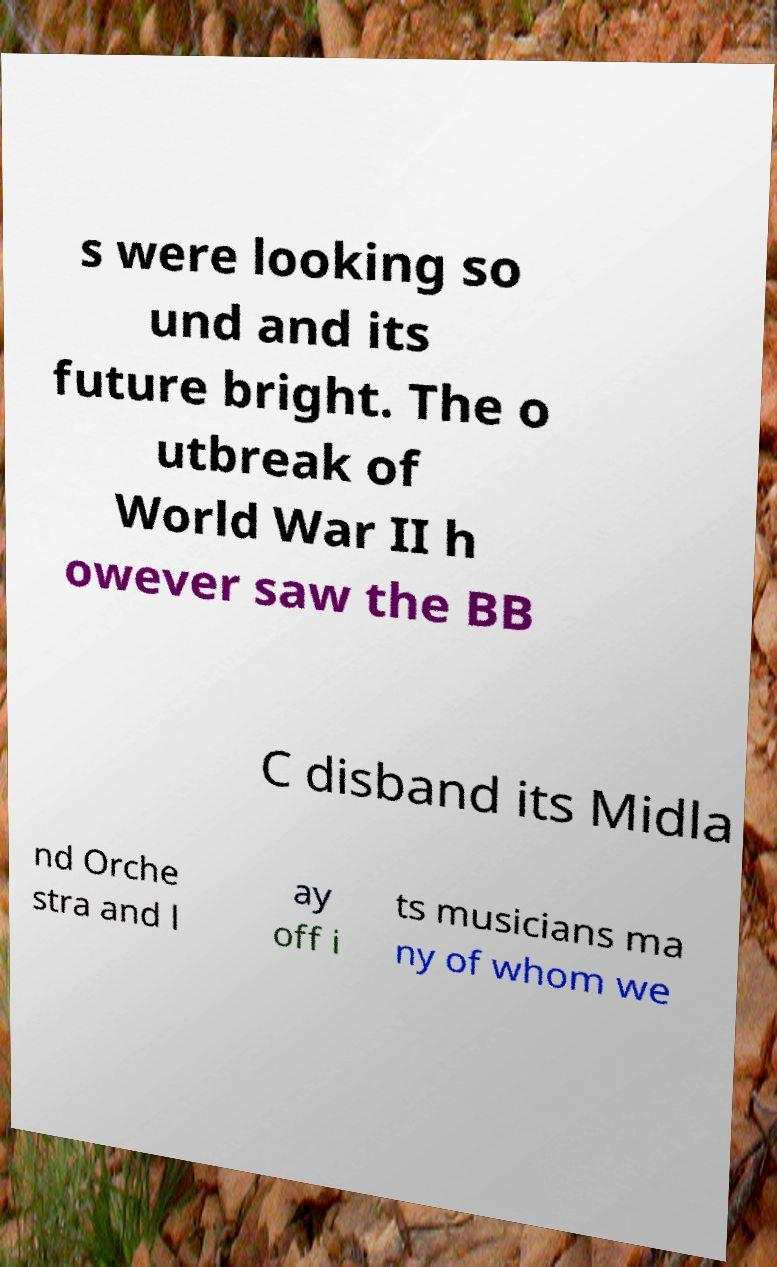Please identify and transcribe the text found in this image. s were looking so und and its future bright. The o utbreak of World War II h owever saw the BB C disband its Midla nd Orche stra and l ay off i ts musicians ma ny of whom we 